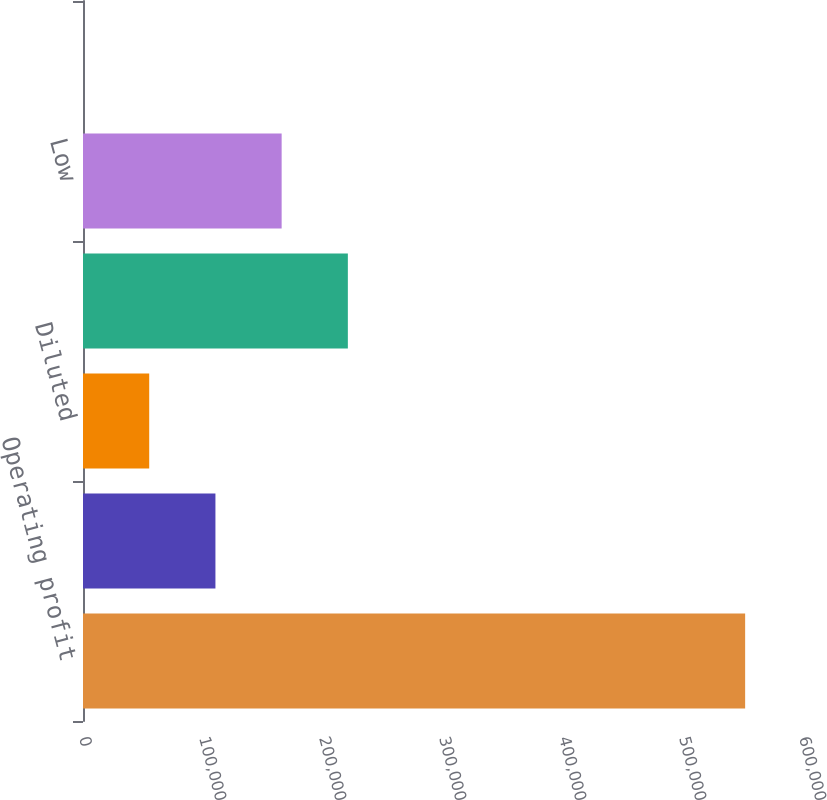<chart> <loc_0><loc_0><loc_500><loc_500><bar_chart><fcel>Operating profit<fcel>Basic<fcel>Diluted<fcel>High<fcel>Low<fcel>Cash dividends declared<nl><fcel>551785<fcel>110358<fcel>55179.8<fcel>220715<fcel>165537<fcel>1.44<nl></chart> 